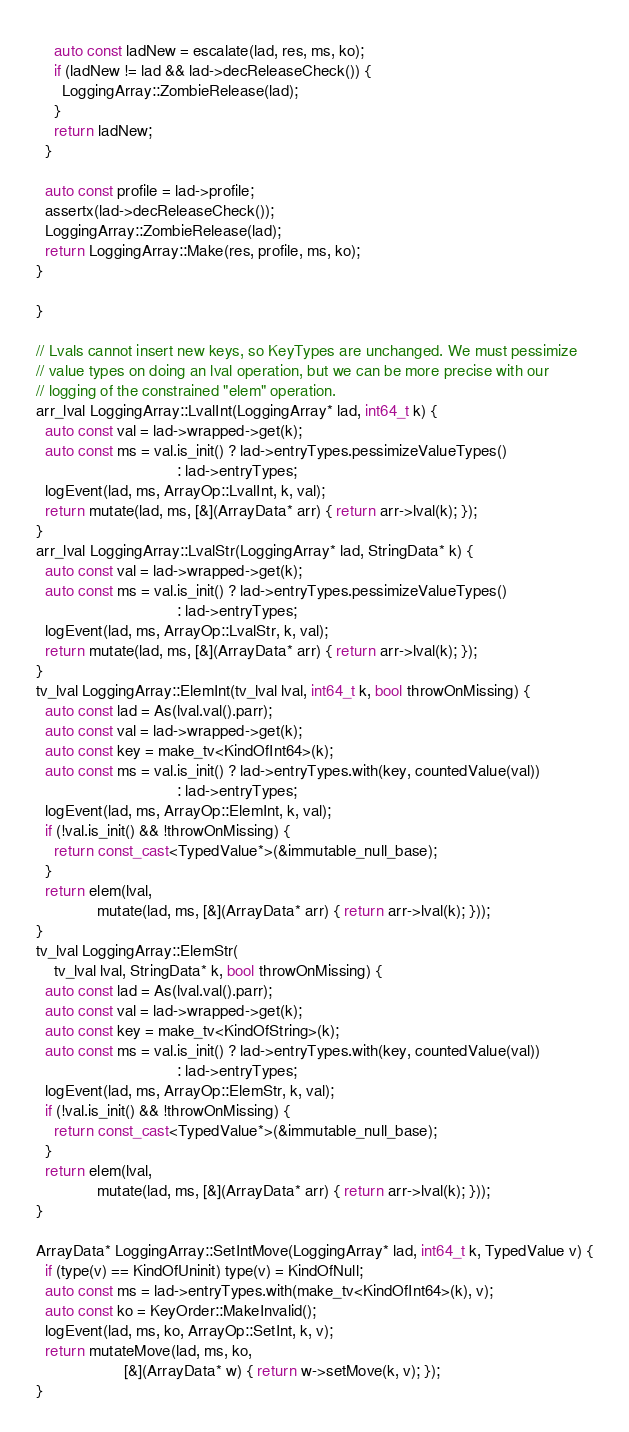<code> <loc_0><loc_0><loc_500><loc_500><_C++_>    auto const ladNew = escalate(lad, res, ms, ko);
    if (ladNew != lad && lad->decReleaseCheck()) {
      LoggingArray::ZombieRelease(lad);
    }
    return ladNew;
  }

  auto const profile = lad->profile;
  assertx(lad->decReleaseCheck());
  LoggingArray::ZombieRelease(lad);
  return LoggingArray::Make(res, profile, ms, ko);
}

}

// Lvals cannot insert new keys, so KeyTypes are unchanged. We must pessimize
// value types on doing an lval operation, but we can be more precise with our
// logging of the constrained "elem" operation.
arr_lval LoggingArray::LvalInt(LoggingArray* lad, int64_t k) {
  auto const val = lad->wrapped->get(k);
  auto const ms = val.is_init() ? lad->entryTypes.pessimizeValueTypes()
                                : lad->entryTypes;
  logEvent(lad, ms, ArrayOp::LvalInt, k, val);
  return mutate(lad, ms, [&](ArrayData* arr) { return arr->lval(k); });
}
arr_lval LoggingArray::LvalStr(LoggingArray* lad, StringData* k) {
  auto const val = lad->wrapped->get(k);
  auto const ms = val.is_init() ? lad->entryTypes.pessimizeValueTypes()
                                : lad->entryTypes;
  logEvent(lad, ms, ArrayOp::LvalStr, k, val);
  return mutate(lad, ms, [&](ArrayData* arr) { return arr->lval(k); });
}
tv_lval LoggingArray::ElemInt(tv_lval lval, int64_t k, bool throwOnMissing) {
  auto const lad = As(lval.val().parr);
  auto const val = lad->wrapped->get(k);
  auto const key = make_tv<KindOfInt64>(k);
  auto const ms = val.is_init() ? lad->entryTypes.with(key, countedValue(val))
                                : lad->entryTypes;
  logEvent(lad, ms, ArrayOp::ElemInt, k, val);
  if (!val.is_init() && !throwOnMissing) {
    return const_cast<TypedValue*>(&immutable_null_base);
  }
  return elem(lval,
              mutate(lad, ms, [&](ArrayData* arr) { return arr->lval(k); }));
}
tv_lval LoggingArray::ElemStr(
    tv_lval lval, StringData* k, bool throwOnMissing) {
  auto const lad = As(lval.val().parr);
  auto const val = lad->wrapped->get(k);
  auto const key = make_tv<KindOfString>(k);
  auto const ms = val.is_init() ? lad->entryTypes.with(key, countedValue(val))
                                : lad->entryTypes;
  logEvent(lad, ms, ArrayOp::ElemStr, k, val);
  if (!val.is_init() && !throwOnMissing) {
    return const_cast<TypedValue*>(&immutable_null_base);
  }
  return elem(lval,
              mutate(lad, ms, [&](ArrayData* arr) { return arr->lval(k); }));
}

ArrayData* LoggingArray::SetIntMove(LoggingArray* lad, int64_t k, TypedValue v) {
  if (type(v) == KindOfUninit) type(v) = KindOfNull;
  auto const ms = lad->entryTypes.with(make_tv<KindOfInt64>(k), v);
  auto const ko = KeyOrder::MakeInvalid();
  logEvent(lad, ms, ko, ArrayOp::SetInt, k, v);
  return mutateMove(lad, ms, ko,
                    [&](ArrayData* w) { return w->setMove(k, v); });
}</code> 